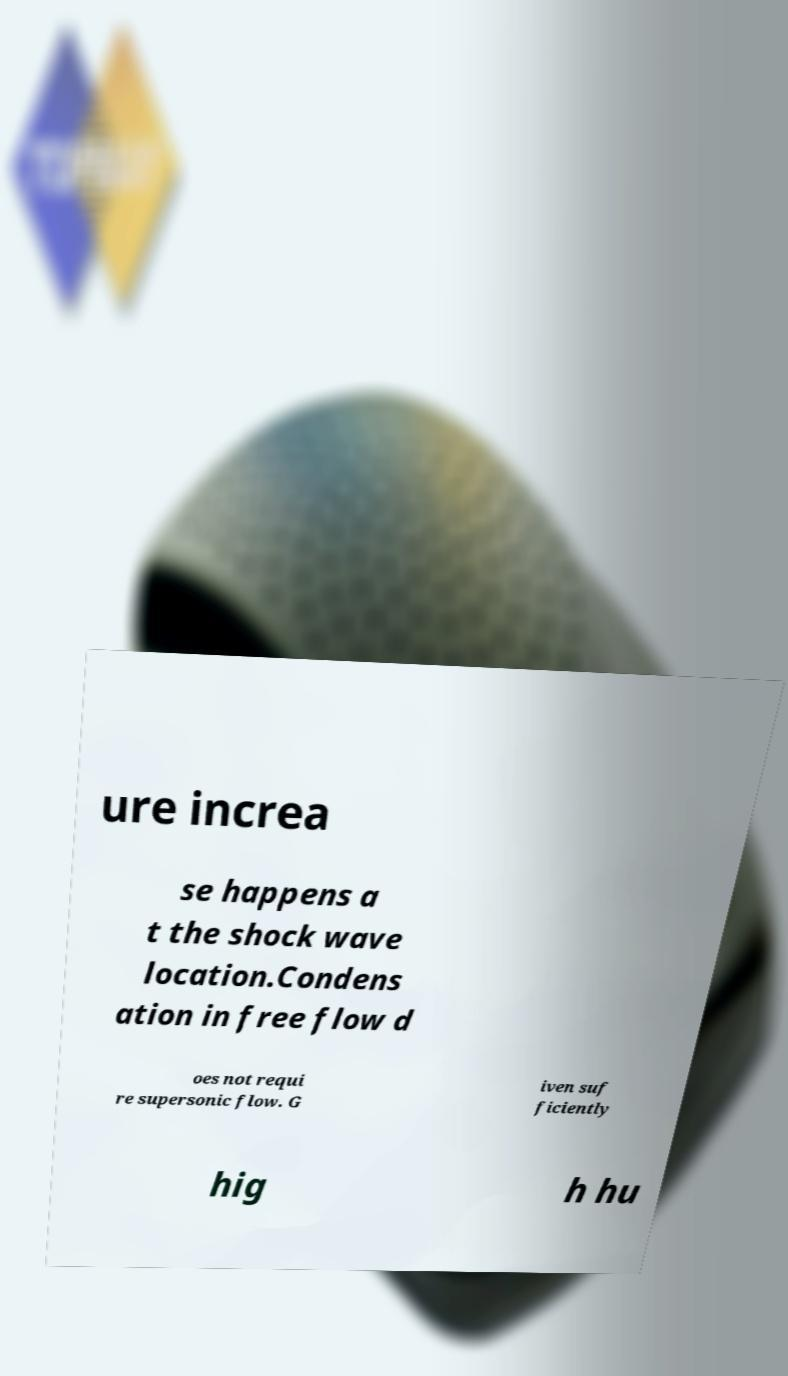Could you extract and type out the text from this image? ure increa se happens a t the shock wave location.Condens ation in free flow d oes not requi re supersonic flow. G iven suf ficiently hig h hu 